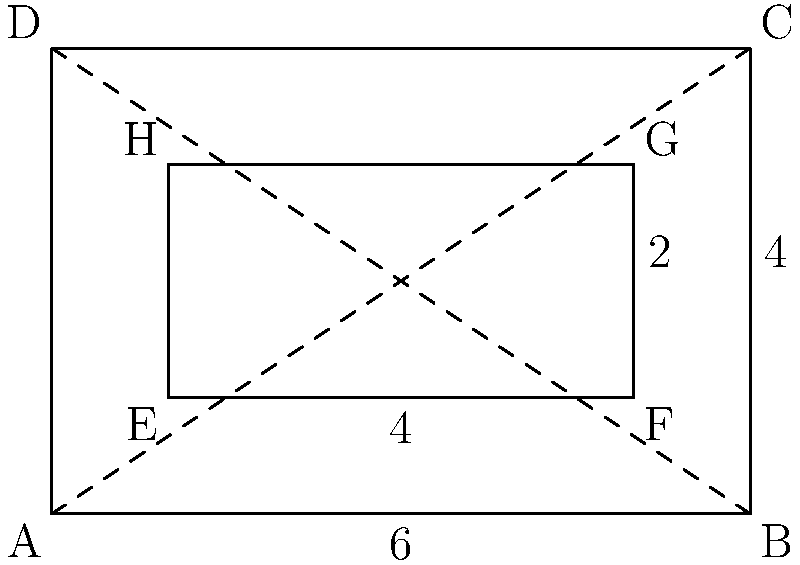A secure voting booth is designed as a rectangular prism with an open top. The outer dimensions are 6 feet long, 4 feet wide, and 7 feet tall. To ensure privacy, an inner booth is created with a 1-foot buffer on all sides except the top. What is the volume of the inner booth in cubic feet? To find the volume of the inner booth, we need to follow these steps:

1. Determine the dimensions of the inner booth:
   - Length: $6 - 2(1) = 4$ feet (1-foot buffer on each side)
   - Width: $4 - 2(1) = 2$ feet (1-foot buffer on each side)
   - Height: $7 - 1 = 6$ feet (1-foot buffer only on the bottom)

2. Calculate the volume using the formula for a rectangular prism:
   $V = l \times w \times h$
   
   Where:
   $V$ = volume
   $l$ = length
   $w$ = width
   $h$ = height

3. Substitute the values:
   $V = 4 \times 2 \times 6$

4. Compute the result:
   $V = 48$ cubic feet

Therefore, the volume of the inner booth is 48 cubic feet.
Answer: 48 cubic feet 